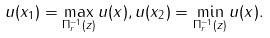Convert formula to latex. <formula><loc_0><loc_0><loc_500><loc_500>u ( x _ { 1 } ) = \max _ { \Pi _ { r } ^ { - 1 } ( z ) } u ( x ) , u ( x _ { 2 } ) = \min _ { \Pi _ { r } ^ { - 1 } ( z ) } u ( x ) .</formula> 